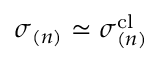Convert formula to latex. <formula><loc_0><loc_0><loc_500><loc_500>\sigma _ { ( n ) } \simeq \sigma _ { ( n ) } ^ { c l }</formula> 